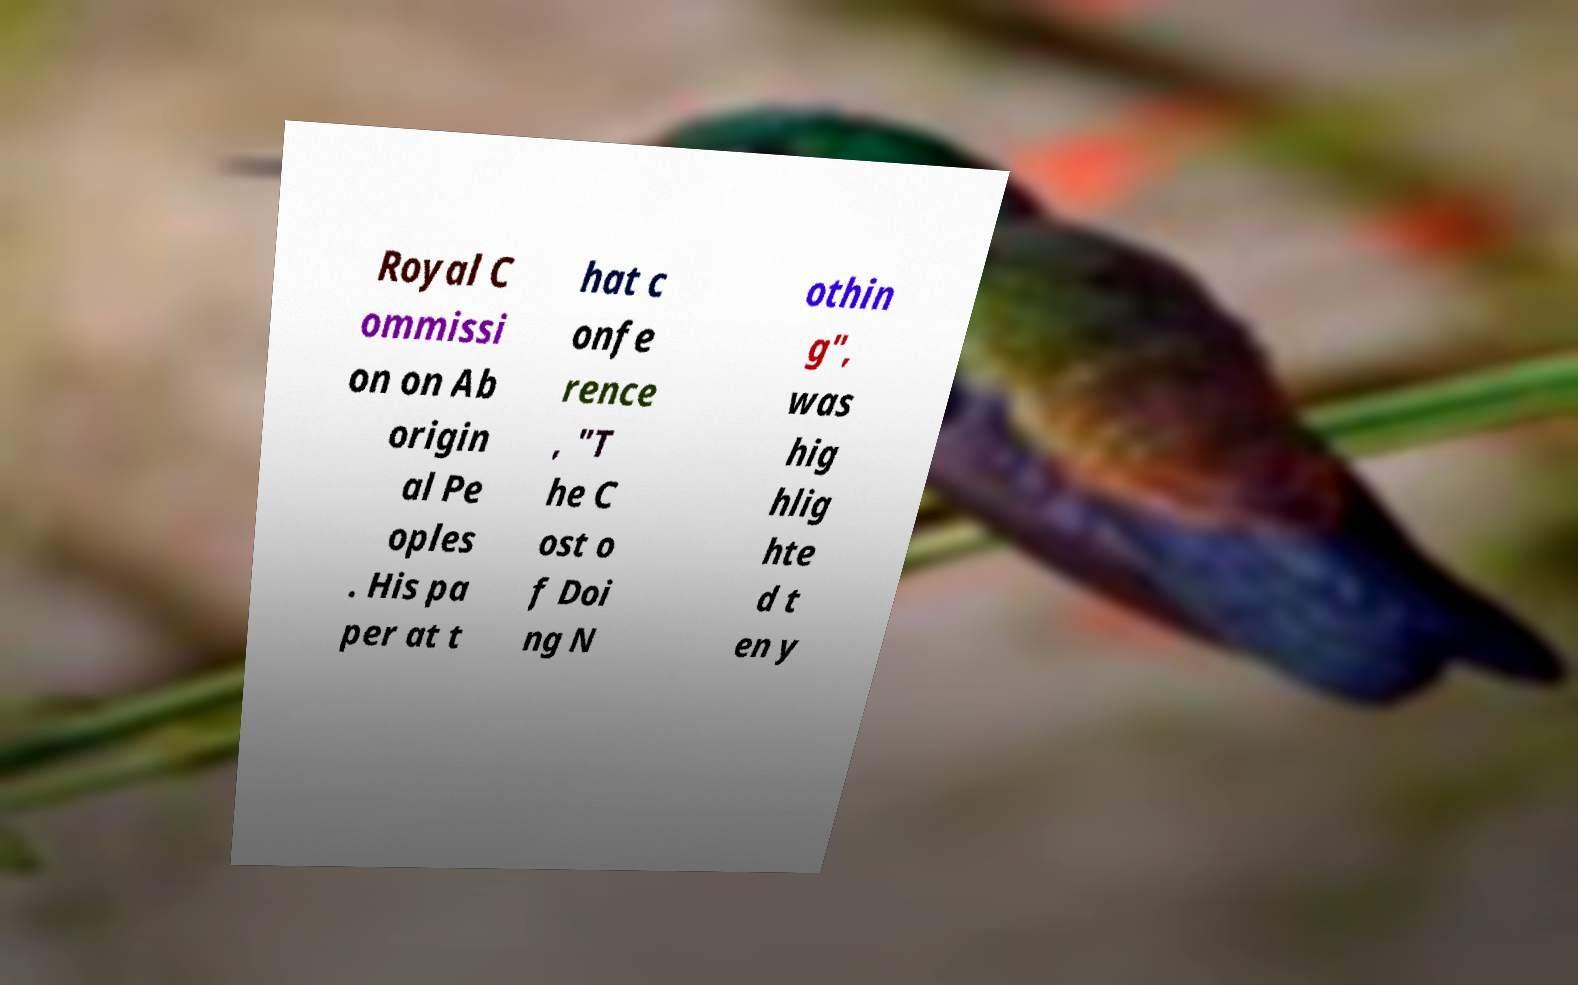Could you assist in decoding the text presented in this image and type it out clearly? Royal C ommissi on on Ab origin al Pe oples . His pa per at t hat c onfe rence , "T he C ost o f Doi ng N othin g", was hig hlig hte d t en y 